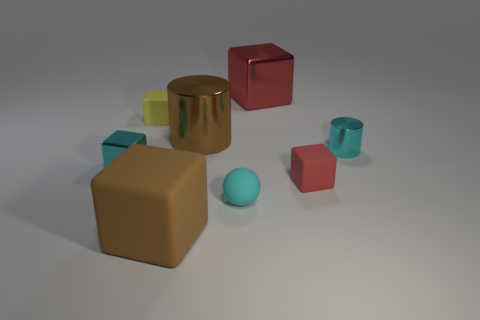Is there a metal cylinder that has the same size as the brown cube?
Offer a terse response. Yes. There is a yellow block that is made of the same material as the tiny sphere; what is its size?
Your answer should be compact. Small. There is a small yellow thing; what shape is it?
Give a very brief answer. Cube. Is the big red object made of the same material as the small cyan cylinder that is right of the tiny yellow matte cube?
Keep it short and to the point. Yes. What number of objects are either green spheres or metal cylinders?
Offer a terse response. 2. Are there any red objects?
Make the answer very short. Yes. What is the shape of the cyan metallic thing that is behind the metal cube that is in front of the cyan cylinder?
Your response must be concise. Cylinder. What number of objects are either metal objects that are to the right of the cyan matte sphere or tiny objects left of the cyan cylinder?
Your response must be concise. 6. There is a red object that is the same size as the brown block; what material is it?
Make the answer very short. Metal. What is the color of the small metallic cylinder?
Offer a terse response. Cyan. 